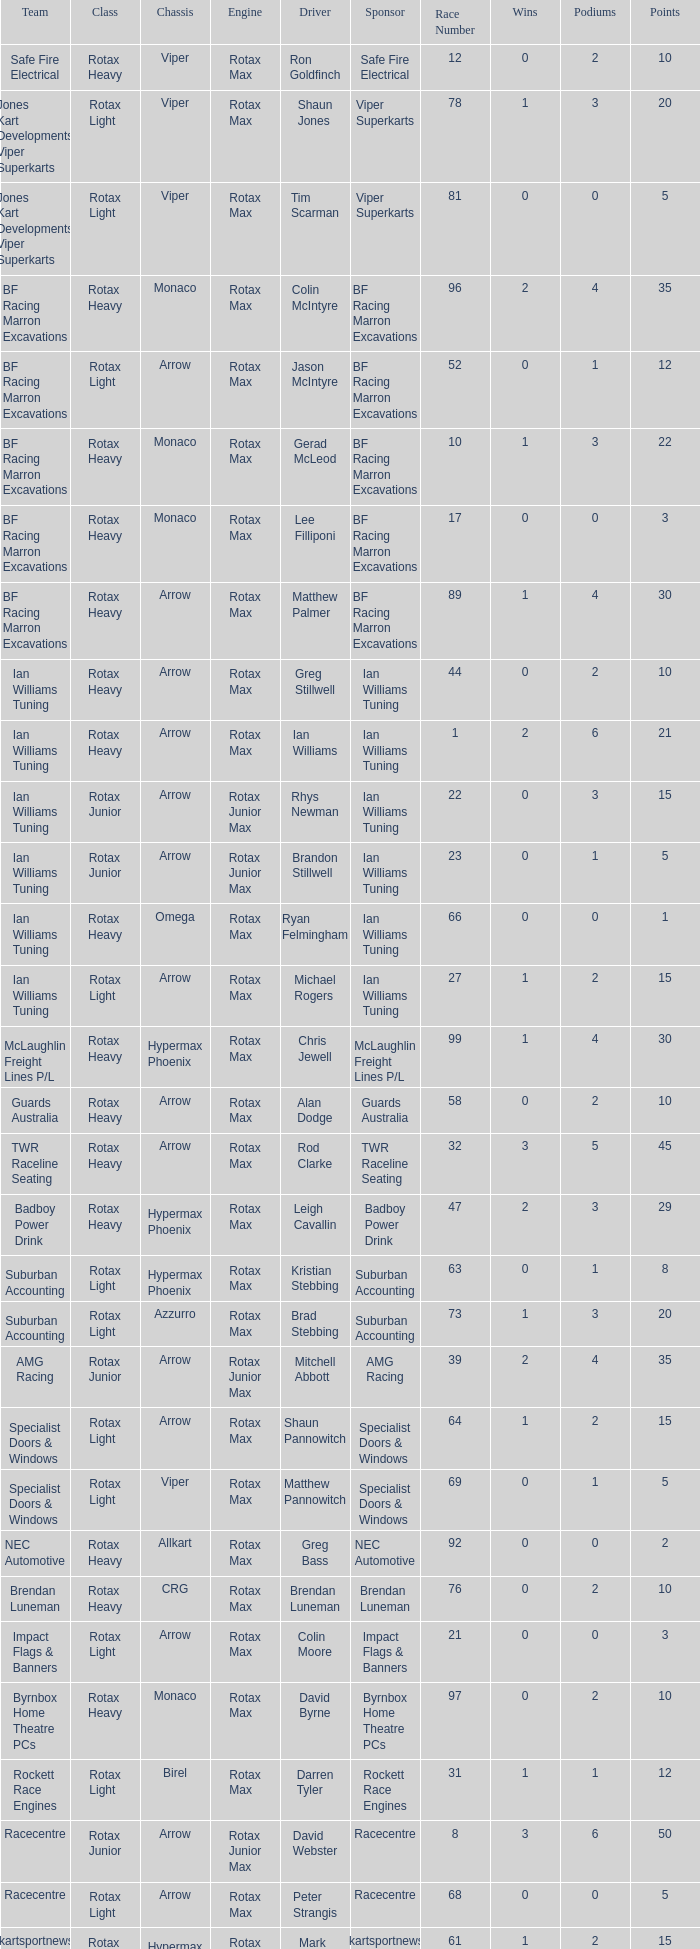What is the name of the driver with a rotax max engine, in the rotax heavy class, with arrow as chassis and on the TWR Raceline Seating team? Rod Clarke. 